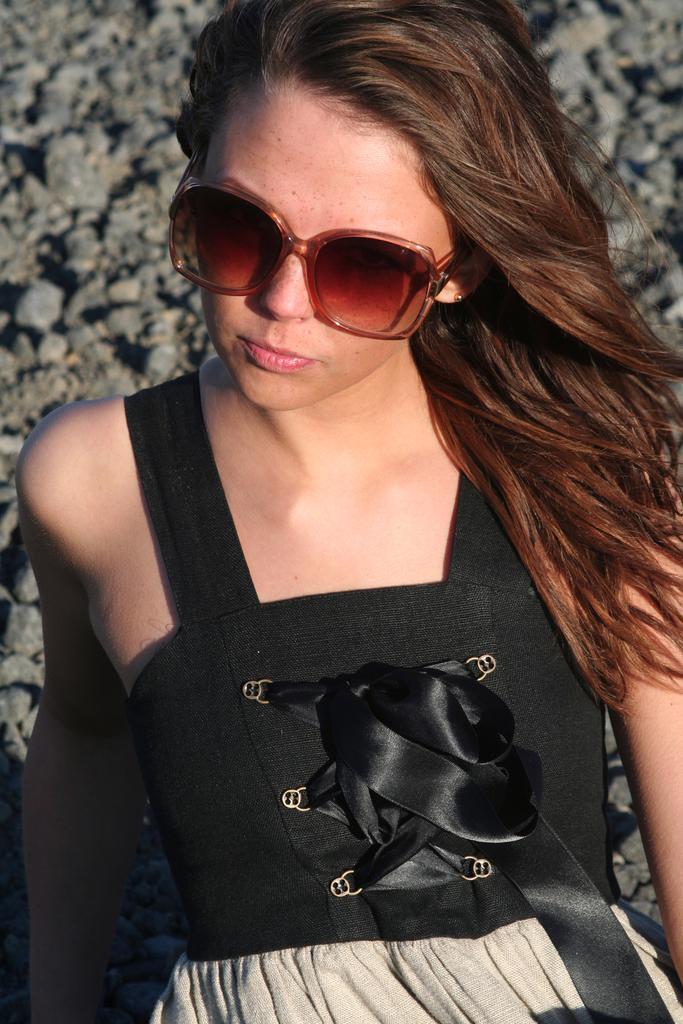In one or two sentences, can you explain what this image depicts? In this picture there is a woman who is wearing goggle and black dress and she is sitting on the floor. In the top left we can see stones. 